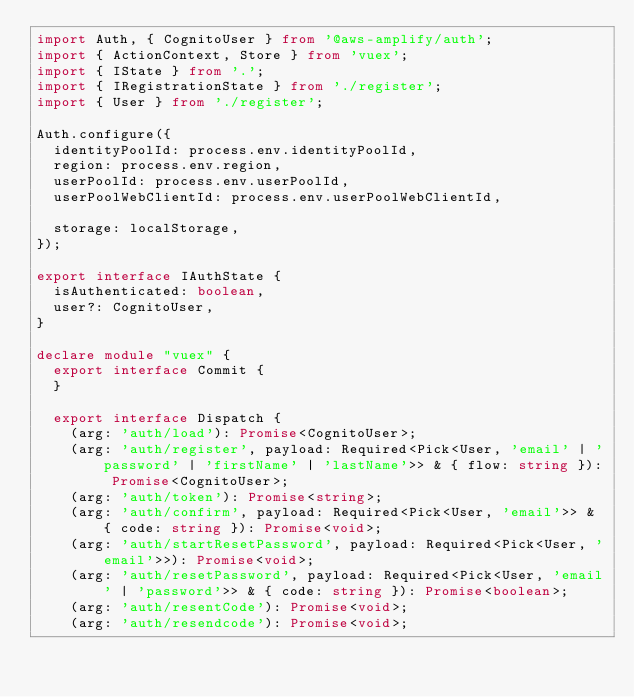Convert code to text. <code><loc_0><loc_0><loc_500><loc_500><_TypeScript_>import Auth, { CognitoUser } from '@aws-amplify/auth';
import { ActionContext, Store } from 'vuex';
import { IState } from '.';
import { IRegistrationState } from './register';
import { User } from './register';

Auth.configure({
  identityPoolId: process.env.identityPoolId,
  region: process.env.region,
  userPoolId: process.env.userPoolId,
  userPoolWebClientId: process.env.userPoolWebClientId,

  storage: localStorage,
});

export interface IAuthState {
  isAuthenticated: boolean,
  user?: CognitoUser,
}

declare module "vuex" {
  export interface Commit {
  }

  export interface Dispatch {
    (arg: 'auth/load'): Promise<CognitoUser>;
    (arg: 'auth/register', payload: Required<Pick<User, 'email' | 'password' | 'firstName' | 'lastName'>> & { flow: string }): Promise<CognitoUser>;
    (arg: 'auth/token'): Promise<string>;
    (arg: 'auth/confirm', payload: Required<Pick<User, 'email'>> & { code: string }): Promise<void>;
    (arg: 'auth/startResetPassword', payload: Required<Pick<User, 'email'>>): Promise<void>;
    (arg: 'auth/resetPassword', payload: Required<Pick<User, 'email' | 'password'>> & { code: string }): Promise<boolean>;
    (arg: 'auth/resentCode'): Promise<void>;
    (arg: 'auth/resendcode'): Promise<void>;</code> 